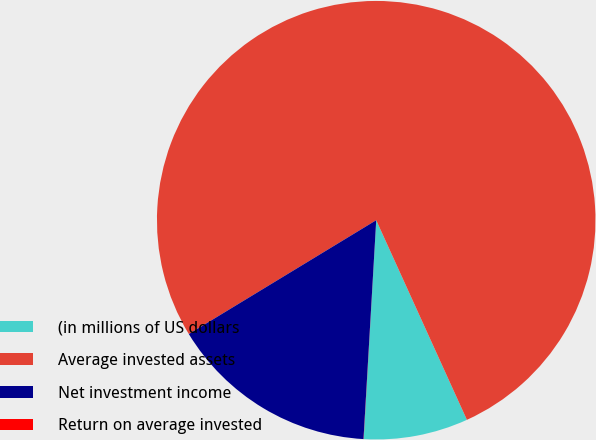<chart> <loc_0><loc_0><loc_500><loc_500><pie_chart><fcel>(in millions of US dollars<fcel>Average invested assets<fcel>Net investment income<fcel>Return on average invested<nl><fcel>7.7%<fcel>76.91%<fcel>15.39%<fcel>0.01%<nl></chart> 